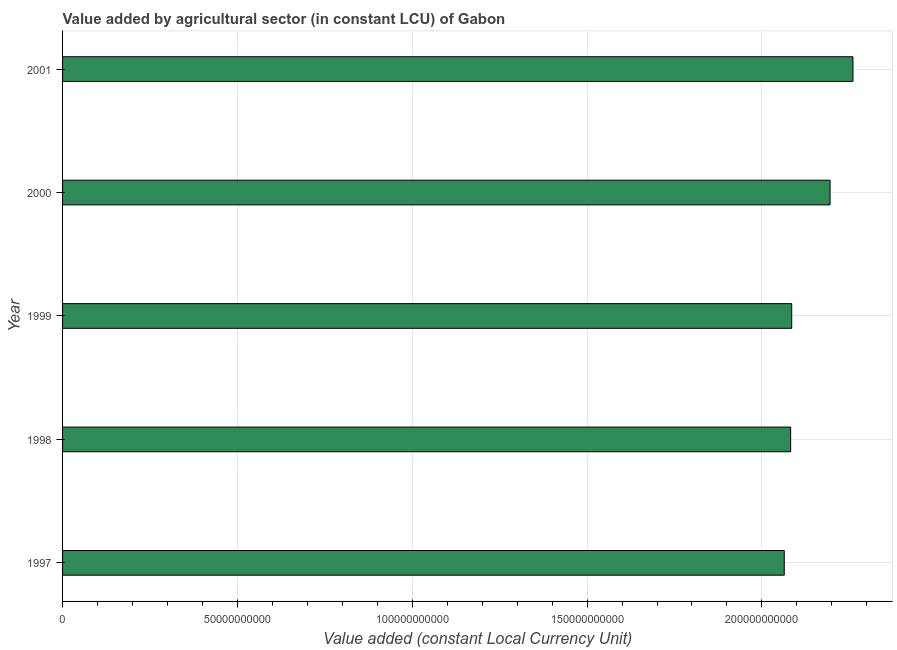Does the graph contain any zero values?
Keep it short and to the point. No. Does the graph contain grids?
Give a very brief answer. Yes. What is the title of the graph?
Offer a very short reply. Value added by agricultural sector (in constant LCU) of Gabon. What is the label or title of the X-axis?
Your answer should be very brief. Value added (constant Local Currency Unit). What is the value added by agriculture sector in 2000?
Make the answer very short. 2.19e+11. Across all years, what is the maximum value added by agriculture sector?
Your answer should be compact. 2.26e+11. Across all years, what is the minimum value added by agriculture sector?
Provide a succinct answer. 2.06e+11. In which year was the value added by agriculture sector minimum?
Keep it short and to the point. 1997. What is the sum of the value added by agriculture sector?
Your answer should be very brief. 1.07e+12. What is the difference between the value added by agriculture sector in 1999 and 2001?
Keep it short and to the point. -1.75e+1. What is the average value added by agriculture sector per year?
Make the answer very short. 2.14e+11. What is the median value added by agriculture sector?
Your answer should be compact. 2.09e+11. In how many years, is the value added by agriculture sector greater than 20000000000 LCU?
Your answer should be very brief. 5. Do a majority of the years between 1999 and 1997 (inclusive) have value added by agriculture sector greater than 130000000000 LCU?
Your answer should be very brief. Yes. What is the ratio of the value added by agriculture sector in 1998 to that in 1999?
Provide a succinct answer. 1. Is the value added by agriculture sector in 1997 less than that in 1998?
Make the answer very short. Yes. What is the difference between the highest and the second highest value added by agriculture sector?
Offer a very short reply. 6.55e+09. Is the sum of the value added by agriculture sector in 1999 and 2000 greater than the maximum value added by agriculture sector across all years?
Offer a very short reply. Yes. What is the difference between the highest and the lowest value added by agriculture sector?
Give a very brief answer. 1.96e+1. How many bars are there?
Your answer should be compact. 5. Are all the bars in the graph horizontal?
Your answer should be compact. Yes. How many years are there in the graph?
Keep it short and to the point. 5. What is the difference between two consecutive major ticks on the X-axis?
Offer a terse response. 5.00e+1. What is the Value added (constant Local Currency Unit) of 1997?
Offer a very short reply. 2.06e+11. What is the Value added (constant Local Currency Unit) in 1998?
Ensure brevity in your answer.  2.08e+11. What is the Value added (constant Local Currency Unit) of 1999?
Keep it short and to the point. 2.09e+11. What is the Value added (constant Local Currency Unit) in 2000?
Your answer should be very brief. 2.19e+11. What is the Value added (constant Local Currency Unit) in 2001?
Provide a short and direct response. 2.26e+11. What is the difference between the Value added (constant Local Currency Unit) in 1997 and 1998?
Make the answer very short. -1.83e+09. What is the difference between the Value added (constant Local Currency Unit) in 1997 and 1999?
Keep it short and to the point. -2.13e+09. What is the difference between the Value added (constant Local Currency Unit) in 1997 and 2000?
Give a very brief answer. -1.31e+1. What is the difference between the Value added (constant Local Currency Unit) in 1997 and 2001?
Ensure brevity in your answer.  -1.96e+1. What is the difference between the Value added (constant Local Currency Unit) in 1998 and 1999?
Offer a very short reply. -3.05e+08. What is the difference between the Value added (constant Local Currency Unit) in 1998 and 2000?
Your response must be concise. -1.13e+1. What is the difference between the Value added (constant Local Currency Unit) in 1998 and 2001?
Offer a very short reply. -1.78e+1. What is the difference between the Value added (constant Local Currency Unit) in 1999 and 2000?
Offer a very short reply. -1.10e+1. What is the difference between the Value added (constant Local Currency Unit) in 1999 and 2001?
Ensure brevity in your answer.  -1.75e+1. What is the difference between the Value added (constant Local Currency Unit) in 2000 and 2001?
Give a very brief answer. -6.55e+09. What is the ratio of the Value added (constant Local Currency Unit) in 1997 to that in 1999?
Your answer should be compact. 0.99. What is the ratio of the Value added (constant Local Currency Unit) in 1997 to that in 2001?
Offer a terse response. 0.91. What is the ratio of the Value added (constant Local Currency Unit) in 1998 to that in 2000?
Offer a very short reply. 0.95. What is the ratio of the Value added (constant Local Currency Unit) in 1998 to that in 2001?
Give a very brief answer. 0.92. What is the ratio of the Value added (constant Local Currency Unit) in 1999 to that in 2001?
Provide a short and direct response. 0.92. 